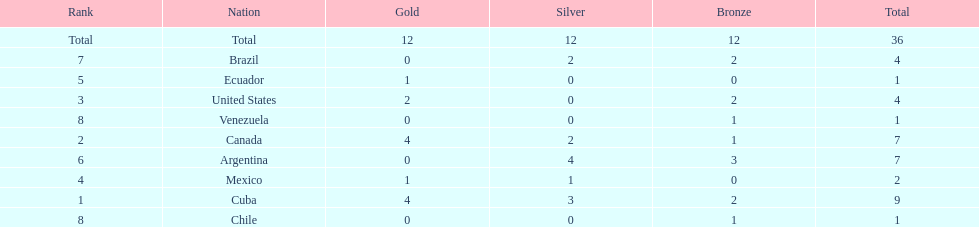Give me the full table as a dictionary. {'header': ['Rank', 'Nation', 'Gold', 'Silver', 'Bronze', 'Total'], 'rows': [['Total', 'Total', '12', '12', '12', '36'], ['7', 'Brazil', '0', '2', '2', '4'], ['5', 'Ecuador', '1', '0', '0', '1'], ['3', 'United States', '2', '0', '2', '4'], ['8', 'Venezuela', '0', '0', '1', '1'], ['2', 'Canada', '4', '2', '1', '7'], ['6', 'Argentina', '0', '4', '3', '7'], ['4', 'Mexico', '1', '1', '0', '2'], ['1', 'Cuba', '4', '3', '2', '9'], ['8', 'Chile', '0', '0', '1', '1']]} Who had more silver medals, cuba or brazil? Cuba. 